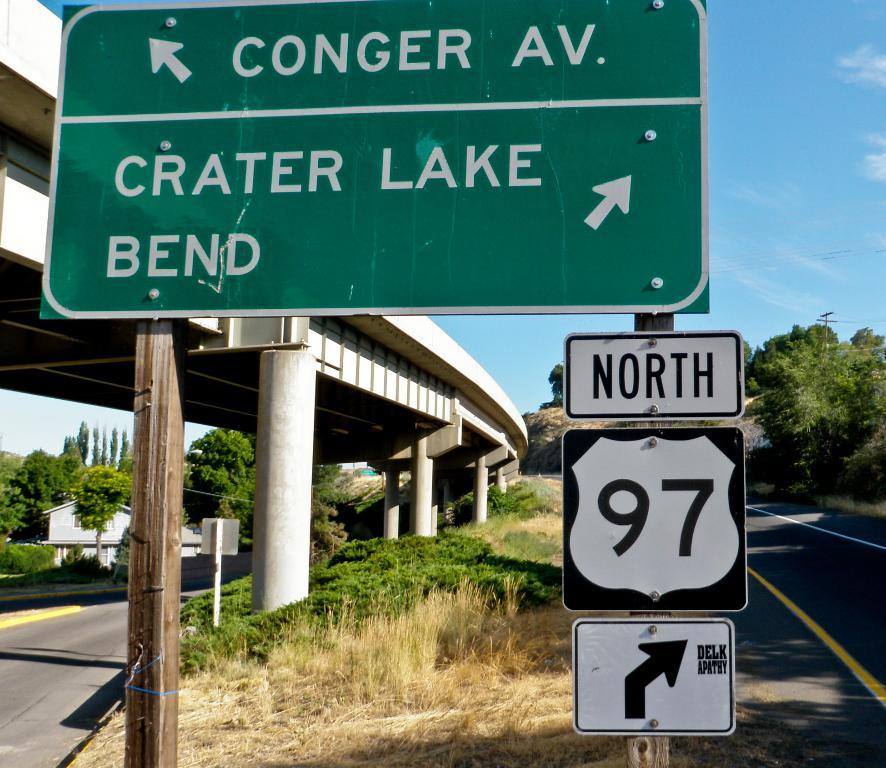Provide a one-sentence caption for the provided image. A freeway overpass has a green sign that says Conger Av and Crater Lake Bend. 